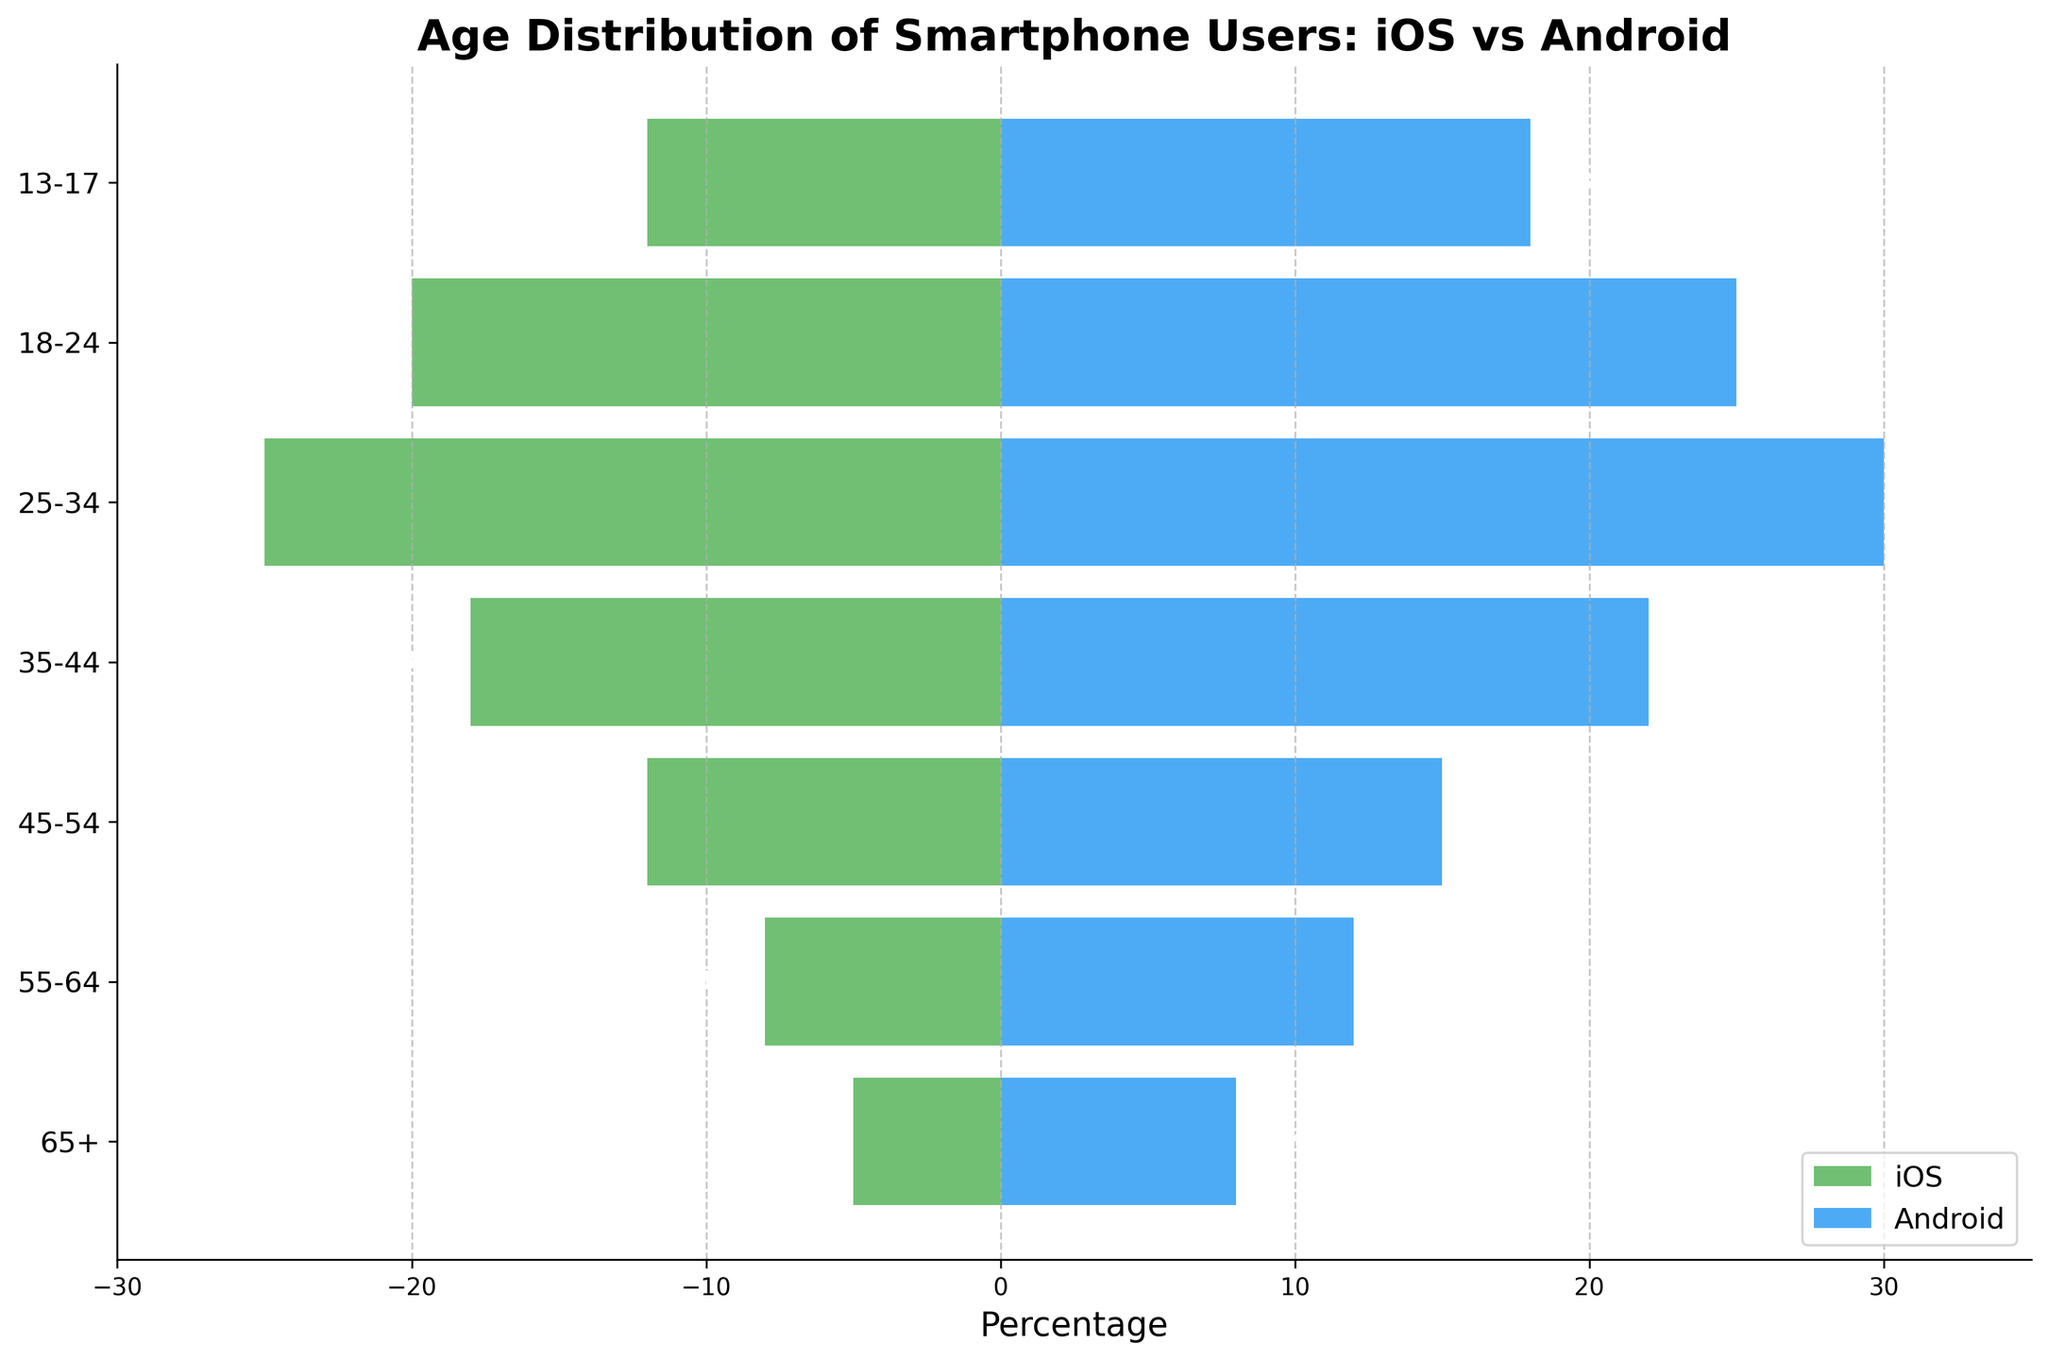What's the overall trend observed for iOS and Android users from younger to older age groups? The graph shows that the percentage of Android users generally increases as we move from younger to older age groups, while the percentage of iOS users decreases. For instance, the age group 18-24 has a high percentage of Android users (25%) compared to iOS users (-20%), whereas the 55-64 age group has 12% Android users compared to -8% iOS users.
Answer: Android users increase, iOS users decrease with age What is the age group with the highest percentage of Android users? The figure shows the percentage bars for each age group. The highest positive value corresponds to the age group 25-34, with 30% Android users.
Answer: 25-34 How much higher is the percentage of Android users in the 18-24 age group compared to iOS users in the same group? The Android percentage in the 18-24 age group is at 25%, while iOS is at -20%. The difference is calculated by converting the negative value to positive and then summing the absolute values: 25% + 20% = 45%.
Answer: 45% Which platform has a higher percentage among teenagers (13-17 age group)? Observing the 13-17 age group, the Android percentage is higher at 18% compared to iOS at -12%.
Answer: Android How many age groups have a higher percentage of Android users compared to iOS users? By comparing each age group, Android users have higher percentages in all groups: 7 groups (13-17, 18-24, 25-34, 35-44, 45-54, 55-64, 65+).
Answer: 7 Which age group shows a relatively significant decline in iOS usage compared to the previous age group? By comparing iOS percentages, the significant decline is from 18-24 (-20%) to 25-34 (-25%) showing a 5% decrease.
Answer: 25-34 For the age group 55-64, how many times larger is the Android user percentage compared to the iOS user percentage? The Android percentage is 12% and the iOS percentage is -8%, converting to absolute values: 12 / 8 = 1.5 times larger.
Answer: 1.5 times 